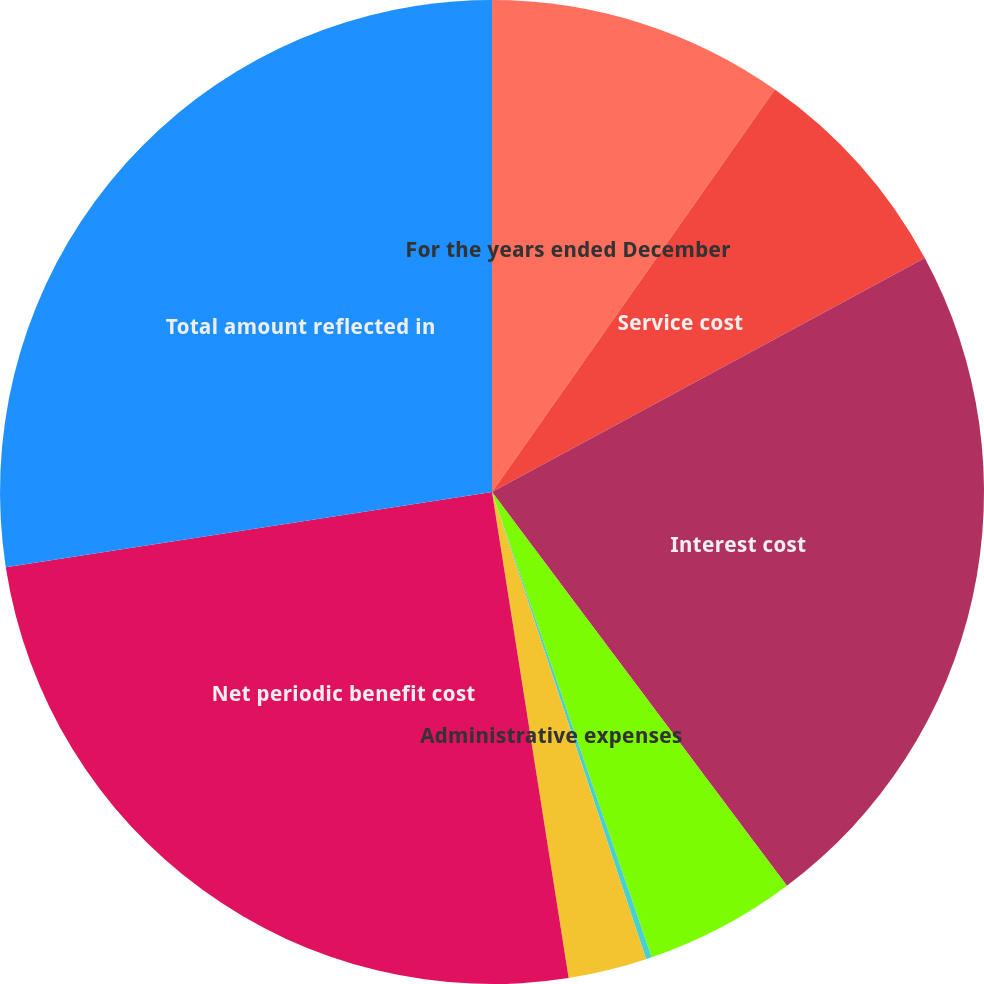<chart> <loc_0><loc_0><loc_500><loc_500><pie_chart><fcel>For the years ended December<fcel>Service cost<fcel>Interest cost<fcel>Amortization of prior service<fcel>Amortization of net loss<fcel>Administrative expenses<fcel>Net periodic benefit cost<fcel>Total amount reflected in<nl><fcel>9.75%<fcel>7.36%<fcel>22.66%<fcel>4.97%<fcel>0.19%<fcel>2.58%<fcel>25.05%<fcel>27.44%<nl></chart> 